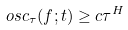Convert formula to latex. <formula><loc_0><loc_0><loc_500><loc_500>o s c _ { \tau } ( f ; t ) \geq c \tau ^ { H }</formula> 